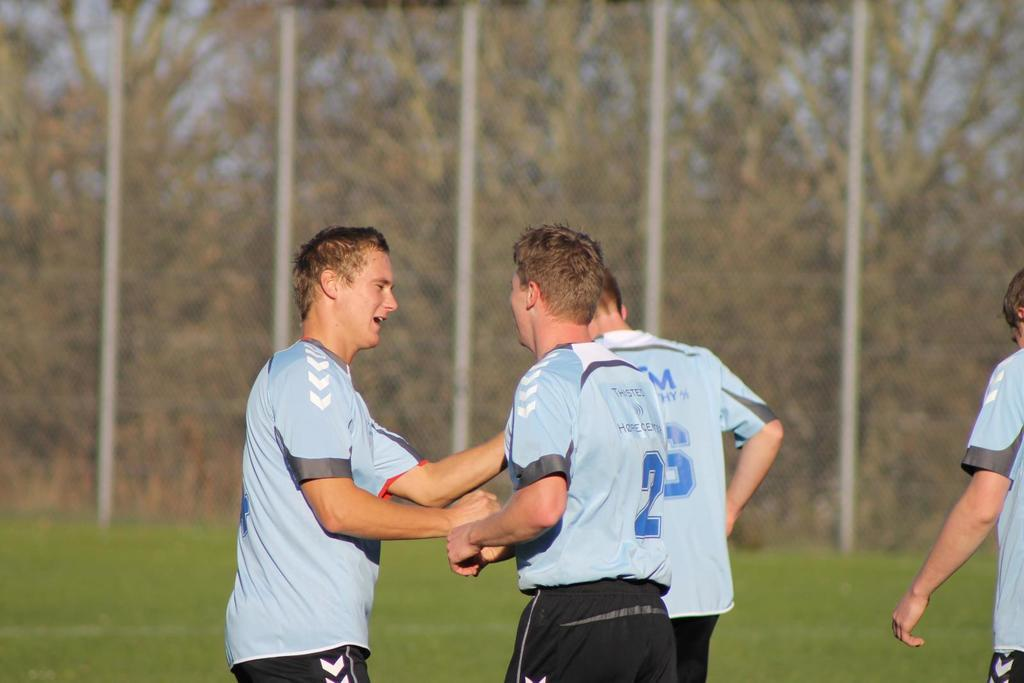What are the people in the image doing? The people in the image are standing on the ground. What type of vegetation is present in the image? There are trees and grass in the image. What object can be seen in the image besides the people and vegetation? There is a pole in the image. What hobbies do the people in the image enjoy? There is no information about the people's hobbies in the image. What songs are being sung by the trees in the image? Trees do not sing songs, and there are no people singing in the image. 